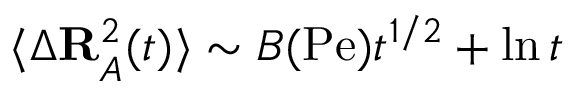Convert formula to latex. <formula><loc_0><loc_0><loc_500><loc_500>\langle \Delta R _ { A } ^ { 2 } ( t ) \rangle \sim B ( P e ) t ^ { 1 / 2 } + \ln t</formula> 